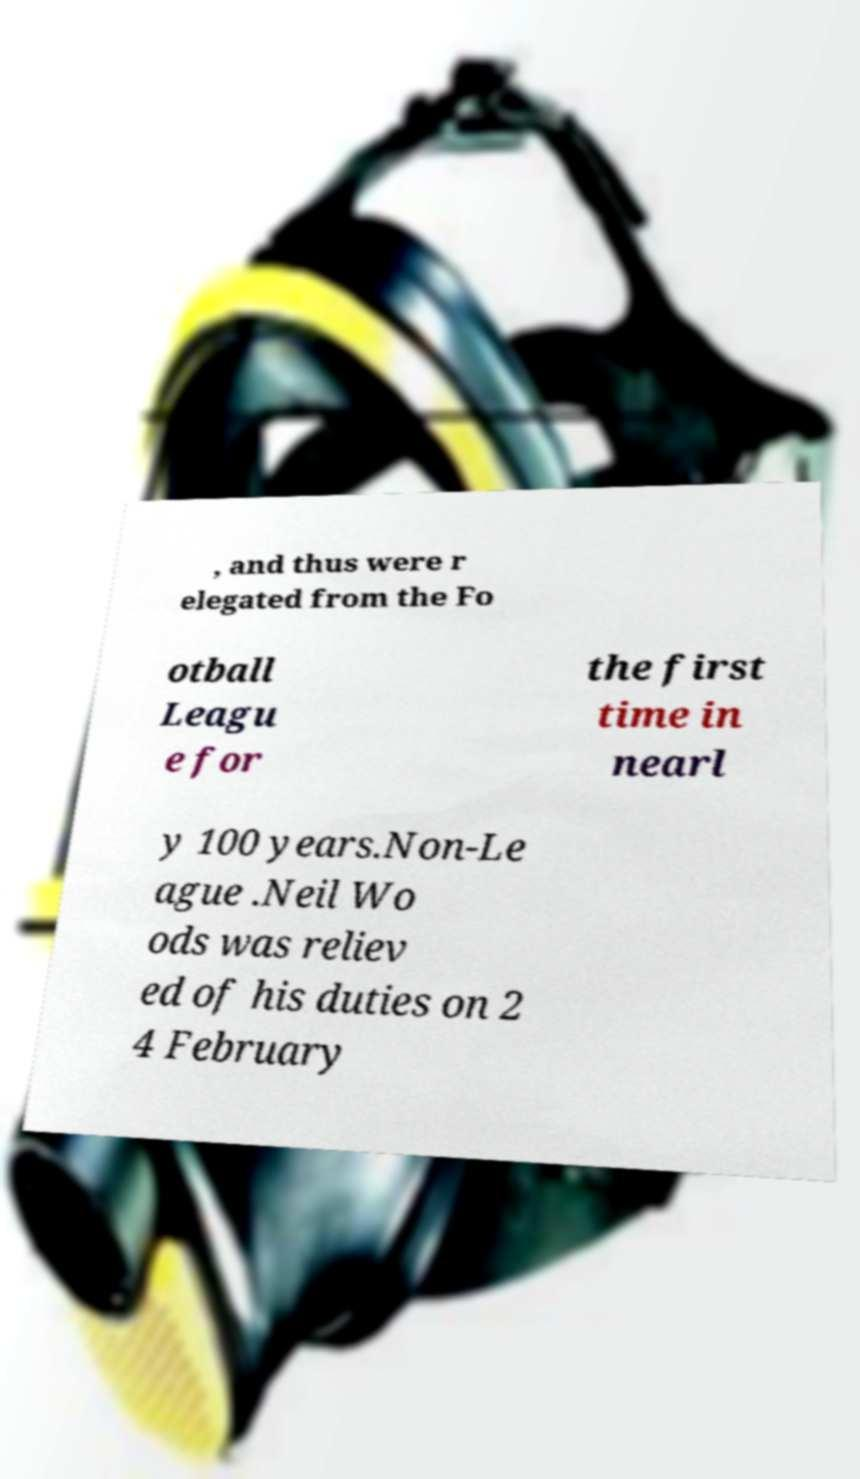Could you assist in decoding the text presented in this image and type it out clearly? , and thus were r elegated from the Fo otball Leagu e for the first time in nearl y 100 years.Non-Le ague .Neil Wo ods was reliev ed of his duties on 2 4 February 